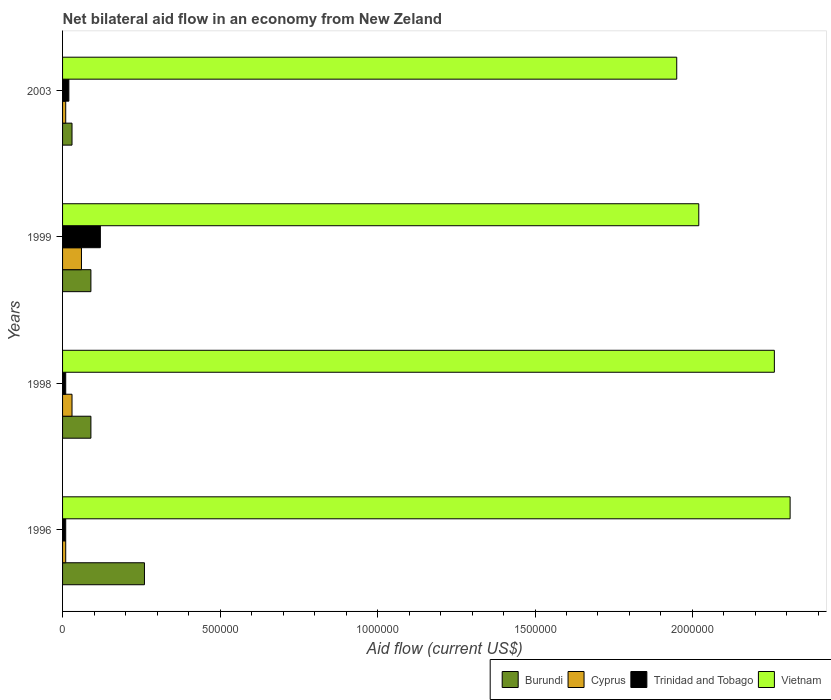How many different coloured bars are there?
Give a very brief answer. 4. Are the number of bars per tick equal to the number of legend labels?
Provide a succinct answer. Yes. Are the number of bars on each tick of the Y-axis equal?
Your answer should be compact. Yes. How many bars are there on the 2nd tick from the bottom?
Offer a terse response. 4. What is the label of the 1st group of bars from the top?
Ensure brevity in your answer.  2003. In how many cases, is the number of bars for a given year not equal to the number of legend labels?
Your answer should be very brief. 0. Across all years, what is the maximum net bilateral aid flow in Vietnam?
Offer a very short reply. 2.31e+06. In which year was the net bilateral aid flow in Cyprus maximum?
Make the answer very short. 1999. What is the total net bilateral aid flow in Vietnam in the graph?
Provide a succinct answer. 8.54e+06. What is the difference between the net bilateral aid flow in Cyprus in 1998 and that in 1999?
Your answer should be very brief. -3.00e+04. What is the average net bilateral aid flow in Burundi per year?
Ensure brevity in your answer.  1.18e+05. In the year 2003, what is the difference between the net bilateral aid flow in Burundi and net bilateral aid flow in Vietnam?
Offer a very short reply. -1.92e+06. Is the net bilateral aid flow in Burundi in 1996 less than that in 1999?
Your answer should be compact. No. What is the difference between the highest and the lowest net bilateral aid flow in Cyprus?
Offer a terse response. 5.00e+04. In how many years, is the net bilateral aid flow in Vietnam greater than the average net bilateral aid flow in Vietnam taken over all years?
Your answer should be very brief. 2. Is it the case that in every year, the sum of the net bilateral aid flow in Vietnam and net bilateral aid flow in Burundi is greater than the sum of net bilateral aid flow in Cyprus and net bilateral aid flow in Trinidad and Tobago?
Keep it short and to the point. No. What does the 4th bar from the top in 1998 represents?
Provide a succinct answer. Burundi. What does the 4th bar from the bottom in 2003 represents?
Offer a very short reply. Vietnam. Is it the case that in every year, the sum of the net bilateral aid flow in Trinidad and Tobago and net bilateral aid flow in Burundi is greater than the net bilateral aid flow in Vietnam?
Keep it short and to the point. No. Are all the bars in the graph horizontal?
Your response must be concise. Yes. How many years are there in the graph?
Ensure brevity in your answer.  4. Are the values on the major ticks of X-axis written in scientific E-notation?
Offer a terse response. No. Does the graph contain any zero values?
Make the answer very short. No. Does the graph contain grids?
Your answer should be very brief. No. Where does the legend appear in the graph?
Your answer should be compact. Bottom right. What is the title of the graph?
Make the answer very short. Net bilateral aid flow in an economy from New Zeland. Does "St. Vincent and the Grenadines" appear as one of the legend labels in the graph?
Offer a terse response. No. What is the label or title of the Y-axis?
Provide a short and direct response. Years. What is the Aid flow (current US$) in Cyprus in 1996?
Your answer should be very brief. 10000. What is the Aid flow (current US$) in Vietnam in 1996?
Offer a terse response. 2.31e+06. What is the Aid flow (current US$) in Cyprus in 1998?
Provide a succinct answer. 3.00e+04. What is the Aid flow (current US$) of Vietnam in 1998?
Provide a succinct answer. 2.26e+06. What is the Aid flow (current US$) in Burundi in 1999?
Offer a terse response. 9.00e+04. What is the Aid flow (current US$) of Trinidad and Tobago in 1999?
Ensure brevity in your answer.  1.20e+05. What is the Aid flow (current US$) of Vietnam in 1999?
Offer a very short reply. 2.02e+06. What is the Aid flow (current US$) in Burundi in 2003?
Your response must be concise. 3.00e+04. What is the Aid flow (current US$) in Cyprus in 2003?
Your answer should be compact. 10000. What is the Aid flow (current US$) of Vietnam in 2003?
Your answer should be compact. 1.95e+06. Across all years, what is the maximum Aid flow (current US$) in Trinidad and Tobago?
Keep it short and to the point. 1.20e+05. Across all years, what is the maximum Aid flow (current US$) in Vietnam?
Your response must be concise. 2.31e+06. Across all years, what is the minimum Aid flow (current US$) in Burundi?
Offer a very short reply. 3.00e+04. Across all years, what is the minimum Aid flow (current US$) of Cyprus?
Provide a succinct answer. 10000. Across all years, what is the minimum Aid flow (current US$) of Trinidad and Tobago?
Offer a very short reply. 10000. Across all years, what is the minimum Aid flow (current US$) in Vietnam?
Make the answer very short. 1.95e+06. What is the total Aid flow (current US$) of Burundi in the graph?
Provide a short and direct response. 4.70e+05. What is the total Aid flow (current US$) of Cyprus in the graph?
Your response must be concise. 1.10e+05. What is the total Aid flow (current US$) in Trinidad and Tobago in the graph?
Offer a very short reply. 1.60e+05. What is the total Aid flow (current US$) of Vietnam in the graph?
Offer a terse response. 8.54e+06. What is the difference between the Aid flow (current US$) of Burundi in 1996 and that in 1998?
Provide a short and direct response. 1.70e+05. What is the difference between the Aid flow (current US$) in Cyprus in 1996 and that in 1998?
Your answer should be very brief. -2.00e+04. What is the difference between the Aid flow (current US$) in Trinidad and Tobago in 1996 and that in 1998?
Make the answer very short. 0. What is the difference between the Aid flow (current US$) of Cyprus in 1996 and that in 1999?
Offer a terse response. -5.00e+04. What is the difference between the Aid flow (current US$) of Trinidad and Tobago in 1996 and that in 1999?
Offer a very short reply. -1.10e+05. What is the difference between the Aid flow (current US$) of Cyprus in 1996 and that in 2003?
Offer a terse response. 0. What is the difference between the Aid flow (current US$) of Trinidad and Tobago in 1996 and that in 2003?
Ensure brevity in your answer.  -10000. What is the difference between the Aid flow (current US$) of Burundi in 1998 and that in 1999?
Make the answer very short. 0. What is the difference between the Aid flow (current US$) in Cyprus in 1998 and that in 2003?
Offer a terse response. 2.00e+04. What is the difference between the Aid flow (current US$) in Burundi in 1999 and that in 2003?
Keep it short and to the point. 6.00e+04. What is the difference between the Aid flow (current US$) in Trinidad and Tobago in 1999 and that in 2003?
Your response must be concise. 1.00e+05. What is the difference between the Aid flow (current US$) in Vietnam in 1999 and that in 2003?
Offer a terse response. 7.00e+04. What is the difference between the Aid flow (current US$) of Burundi in 1996 and the Aid flow (current US$) of Vietnam in 1998?
Offer a very short reply. -2.00e+06. What is the difference between the Aid flow (current US$) of Cyprus in 1996 and the Aid flow (current US$) of Vietnam in 1998?
Offer a very short reply. -2.25e+06. What is the difference between the Aid flow (current US$) in Trinidad and Tobago in 1996 and the Aid flow (current US$) in Vietnam in 1998?
Your answer should be compact. -2.25e+06. What is the difference between the Aid flow (current US$) in Burundi in 1996 and the Aid flow (current US$) in Vietnam in 1999?
Make the answer very short. -1.76e+06. What is the difference between the Aid flow (current US$) in Cyprus in 1996 and the Aid flow (current US$) in Trinidad and Tobago in 1999?
Offer a terse response. -1.10e+05. What is the difference between the Aid flow (current US$) in Cyprus in 1996 and the Aid flow (current US$) in Vietnam in 1999?
Give a very brief answer. -2.01e+06. What is the difference between the Aid flow (current US$) in Trinidad and Tobago in 1996 and the Aid flow (current US$) in Vietnam in 1999?
Ensure brevity in your answer.  -2.01e+06. What is the difference between the Aid flow (current US$) of Burundi in 1996 and the Aid flow (current US$) of Vietnam in 2003?
Your answer should be compact. -1.69e+06. What is the difference between the Aid flow (current US$) in Cyprus in 1996 and the Aid flow (current US$) in Trinidad and Tobago in 2003?
Your answer should be very brief. -10000. What is the difference between the Aid flow (current US$) of Cyprus in 1996 and the Aid flow (current US$) of Vietnam in 2003?
Your answer should be very brief. -1.94e+06. What is the difference between the Aid flow (current US$) of Trinidad and Tobago in 1996 and the Aid flow (current US$) of Vietnam in 2003?
Offer a terse response. -1.94e+06. What is the difference between the Aid flow (current US$) of Burundi in 1998 and the Aid flow (current US$) of Cyprus in 1999?
Your response must be concise. 3.00e+04. What is the difference between the Aid flow (current US$) of Burundi in 1998 and the Aid flow (current US$) of Vietnam in 1999?
Give a very brief answer. -1.93e+06. What is the difference between the Aid flow (current US$) of Cyprus in 1998 and the Aid flow (current US$) of Vietnam in 1999?
Keep it short and to the point. -1.99e+06. What is the difference between the Aid flow (current US$) of Trinidad and Tobago in 1998 and the Aid flow (current US$) of Vietnam in 1999?
Give a very brief answer. -2.01e+06. What is the difference between the Aid flow (current US$) in Burundi in 1998 and the Aid flow (current US$) in Cyprus in 2003?
Provide a short and direct response. 8.00e+04. What is the difference between the Aid flow (current US$) in Burundi in 1998 and the Aid flow (current US$) in Trinidad and Tobago in 2003?
Give a very brief answer. 7.00e+04. What is the difference between the Aid flow (current US$) of Burundi in 1998 and the Aid flow (current US$) of Vietnam in 2003?
Offer a very short reply. -1.86e+06. What is the difference between the Aid flow (current US$) in Cyprus in 1998 and the Aid flow (current US$) in Trinidad and Tobago in 2003?
Give a very brief answer. 10000. What is the difference between the Aid flow (current US$) of Cyprus in 1998 and the Aid flow (current US$) of Vietnam in 2003?
Provide a succinct answer. -1.92e+06. What is the difference between the Aid flow (current US$) of Trinidad and Tobago in 1998 and the Aid flow (current US$) of Vietnam in 2003?
Your answer should be very brief. -1.94e+06. What is the difference between the Aid flow (current US$) of Burundi in 1999 and the Aid flow (current US$) of Vietnam in 2003?
Your response must be concise. -1.86e+06. What is the difference between the Aid flow (current US$) in Cyprus in 1999 and the Aid flow (current US$) in Vietnam in 2003?
Ensure brevity in your answer.  -1.89e+06. What is the difference between the Aid flow (current US$) of Trinidad and Tobago in 1999 and the Aid flow (current US$) of Vietnam in 2003?
Give a very brief answer. -1.83e+06. What is the average Aid flow (current US$) in Burundi per year?
Offer a terse response. 1.18e+05. What is the average Aid flow (current US$) in Cyprus per year?
Keep it short and to the point. 2.75e+04. What is the average Aid flow (current US$) in Trinidad and Tobago per year?
Make the answer very short. 4.00e+04. What is the average Aid flow (current US$) of Vietnam per year?
Ensure brevity in your answer.  2.14e+06. In the year 1996, what is the difference between the Aid flow (current US$) of Burundi and Aid flow (current US$) of Trinidad and Tobago?
Ensure brevity in your answer.  2.50e+05. In the year 1996, what is the difference between the Aid flow (current US$) in Burundi and Aid flow (current US$) in Vietnam?
Keep it short and to the point. -2.05e+06. In the year 1996, what is the difference between the Aid flow (current US$) in Cyprus and Aid flow (current US$) in Vietnam?
Offer a very short reply. -2.30e+06. In the year 1996, what is the difference between the Aid flow (current US$) in Trinidad and Tobago and Aid flow (current US$) in Vietnam?
Ensure brevity in your answer.  -2.30e+06. In the year 1998, what is the difference between the Aid flow (current US$) of Burundi and Aid flow (current US$) of Cyprus?
Ensure brevity in your answer.  6.00e+04. In the year 1998, what is the difference between the Aid flow (current US$) in Burundi and Aid flow (current US$) in Trinidad and Tobago?
Make the answer very short. 8.00e+04. In the year 1998, what is the difference between the Aid flow (current US$) in Burundi and Aid flow (current US$) in Vietnam?
Keep it short and to the point. -2.17e+06. In the year 1998, what is the difference between the Aid flow (current US$) in Cyprus and Aid flow (current US$) in Trinidad and Tobago?
Provide a succinct answer. 2.00e+04. In the year 1998, what is the difference between the Aid flow (current US$) in Cyprus and Aid flow (current US$) in Vietnam?
Provide a succinct answer. -2.23e+06. In the year 1998, what is the difference between the Aid flow (current US$) in Trinidad and Tobago and Aid flow (current US$) in Vietnam?
Give a very brief answer. -2.25e+06. In the year 1999, what is the difference between the Aid flow (current US$) of Burundi and Aid flow (current US$) of Cyprus?
Your response must be concise. 3.00e+04. In the year 1999, what is the difference between the Aid flow (current US$) in Burundi and Aid flow (current US$) in Vietnam?
Make the answer very short. -1.93e+06. In the year 1999, what is the difference between the Aid flow (current US$) in Cyprus and Aid flow (current US$) in Trinidad and Tobago?
Make the answer very short. -6.00e+04. In the year 1999, what is the difference between the Aid flow (current US$) in Cyprus and Aid flow (current US$) in Vietnam?
Ensure brevity in your answer.  -1.96e+06. In the year 1999, what is the difference between the Aid flow (current US$) of Trinidad and Tobago and Aid flow (current US$) of Vietnam?
Make the answer very short. -1.90e+06. In the year 2003, what is the difference between the Aid flow (current US$) of Burundi and Aid flow (current US$) of Cyprus?
Make the answer very short. 2.00e+04. In the year 2003, what is the difference between the Aid flow (current US$) in Burundi and Aid flow (current US$) in Vietnam?
Make the answer very short. -1.92e+06. In the year 2003, what is the difference between the Aid flow (current US$) in Cyprus and Aid flow (current US$) in Trinidad and Tobago?
Your answer should be compact. -10000. In the year 2003, what is the difference between the Aid flow (current US$) in Cyprus and Aid flow (current US$) in Vietnam?
Offer a terse response. -1.94e+06. In the year 2003, what is the difference between the Aid flow (current US$) in Trinidad and Tobago and Aid flow (current US$) in Vietnam?
Ensure brevity in your answer.  -1.93e+06. What is the ratio of the Aid flow (current US$) of Burundi in 1996 to that in 1998?
Keep it short and to the point. 2.89. What is the ratio of the Aid flow (current US$) of Cyprus in 1996 to that in 1998?
Provide a succinct answer. 0.33. What is the ratio of the Aid flow (current US$) of Trinidad and Tobago in 1996 to that in 1998?
Give a very brief answer. 1. What is the ratio of the Aid flow (current US$) in Vietnam in 1996 to that in 1998?
Ensure brevity in your answer.  1.02. What is the ratio of the Aid flow (current US$) in Burundi in 1996 to that in 1999?
Your answer should be compact. 2.89. What is the ratio of the Aid flow (current US$) in Trinidad and Tobago in 1996 to that in 1999?
Ensure brevity in your answer.  0.08. What is the ratio of the Aid flow (current US$) of Vietnam in 1996 to that in 1999?
Offer a very short reply. 1.14. What is the ratio of the Aid flow (current US$) in Burundi in 1996 to that in 2003?
Offer a very short reply. 8.67. What is the ratio of the Aid flow (current US$) of Trinidad and Tobago in 1996 to that in 2003?
Your answer should be compact. 0.5. What is the ratio of the Aid flow (current US$) of Vietnam in 1996 to that in 2003?
Your answer should be compact. 1.18. What is the ratio of the Aid flow (current US$) in Burundi in 1998 to that in 1999?
Offer a terse response. 1. What is the ratio of the Aid flow (current US$) of Trinidad and Tobago in 1998 to that in 1999?
Keep it short and to the point. 0.08. What is the ratio of the Aid flow (current US$) in Vietnam in 1998 to that in 1999?
Make the answer very short. 1.12. What is the ratio of the Aid flow (current US$) in Vietnam in 1998 to that in 2003?
Offer a very short reply. 1.16. What is the ratio of the Aid flow (current US$) of Burundi in 1999 to that in 2003?
Make the answer very short. 3. What is the ratio of the Aid flow (current US$) in Vietnam in 1999 to that in 2003?
Provide a succinct answer. 1.04. What is the difference between the highest and the second highest Aid flow (current US$) in Cyprus?
Provide a succinct answer. 3.00e+04. What is the difference between the highest and the second highest Aid flow (current US$) in Vietnam?
Provide a short and direct response. 5.00e+04. What is the difference between the highest and the lowest Aid flow (current US$) in Cyprus?
Keep it short and to the point. 5.00e+04. What is the difference between the highest and the lowest Aid flow (current US$) in Trinidad and Tobago?
Provide a short and direct response. 1.10e+05. What is the difference between the highest and the lowest Aid flow (current US$) of Vietnam?
Give a very brief answer. 3.60e+05. 